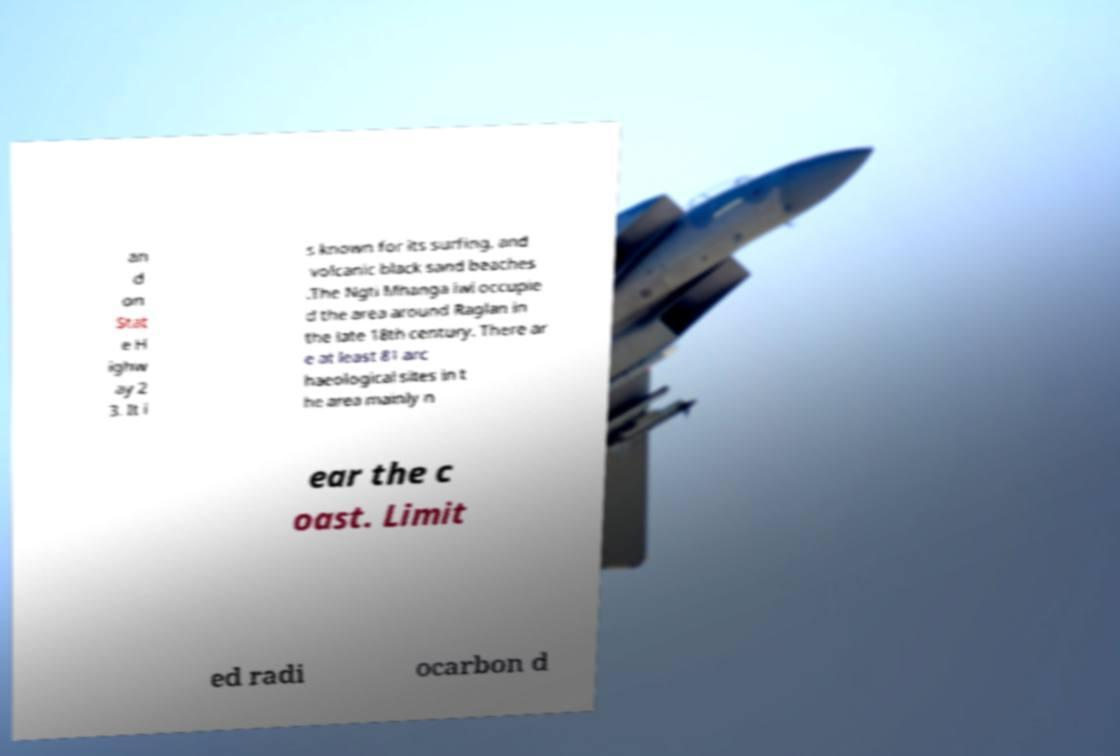I need the written content from this picture converted into text. Can you do that? an d on Stat e H ighw ay 2 3. It i s known for its surfing, and volcanic black sand beaches .The Ngti Mhanga iwi occupie d the area around Raglan in the late 18th century. There ar e at least 81 arc haeological sites in t he area mainly n ear the c oast. Limit ed radi ocarbon d 